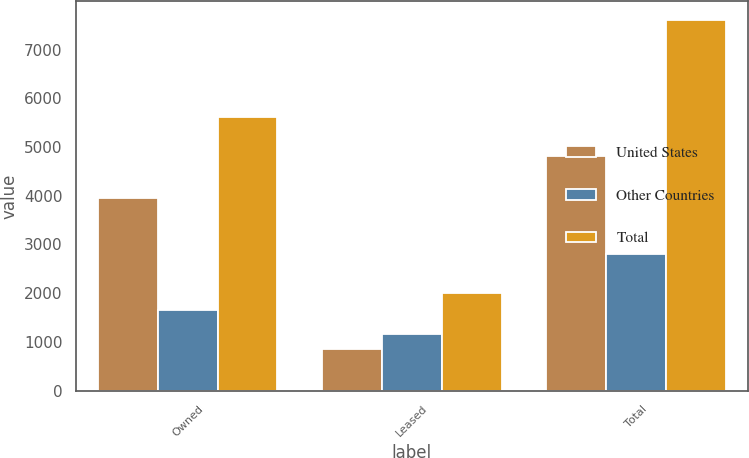Convert chart. <chart><loc_0><loc_0><loc_500><loc_500><stacked_bar_chart><ecel><fcel>Owned<fcel>Leased<fcel>Total<nl><fcel>United States<fcel>3964<fcel>845<fcel>4809<nl><fcel>Other Countries<fcel>1652<fcel>1153<fcel>2805<nl><fcel>Total<fcel>5616<fcel>1998<fcel>7614<nl></chart> 